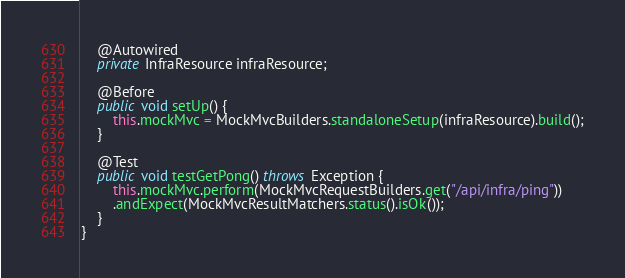<code> <loc_0><loc_0><loc_500><loc_500><_Java_>	@Autowired
	private InfraResource infraResource;
	
	@Before
	public void setUp() {
		this.mockMvc = MockMvcBuilders.standaloneSetup(infraResource).build();
	}
	
	@Test
	public void testGetPong() throws Exception {
		this.mockMvc.perform(MockMvcRequestBuilders.get("/api/infra/ping"))
		.andExpect(MockMvcResultMatchers.status().isOk());
	}
}</code> 